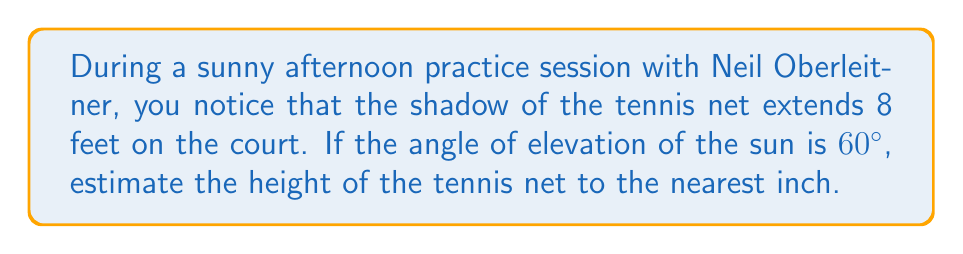Solve this math problem. To solve this problem, we'll use trigonometry, specifically the tangent function. Let's break it down step-by-step:

1) First, let's visualize the situation:

[asy]
import geometry;

size(200);
pair A = (0,0), B = (8,0), C = (0,4);
draw(A--B--C--A);
draw((-1,0)--(9,0), arrow=Arrow(TeXHead));
draw((0,-1)--(0,5), arrow=Arrow(TeXHead));
label("8 ft", (4,0), S);
label("h", (0,2), W);
label("60°", (0,0), NE);
label("x", (9,0), S);
label("y", (0,5), W);
[/asy]

2) In this right triangle, we know:
   - The adjacent side (shadow length) is 8 feet
   - The angle of elevation is 60°
   - We need to find the opposite side (net height)

3) The tangent of an angle in a right triangle is the ratio of the opposite side to the adjacent side:

   $$ \tan \theta = \frac{\text{opposite}}{\text{adjacent}} $$

4) We can write this as an equation:

   $$ \tan 60° = \frac{\text{net height}}{8} $$

5) We know that $\tan 60° = \sqrt{3}$, so we can substitute this:

   $$ \sqrt{3} = \frac{\text{net height}}{8} $$

6) To solve for the net height, multiply both sides by 8:

   $$ 8\sqrt{3} = \text{net height} $$

7) Calculate the result:
   $$ 8\sqrt{3} \approx 13.856 \text{ feet} $$

8) Convert to inches (1 foot = 12 inches):
   $$ 13.856 \text{ feet} \times 12 \text{ inches/foot} \approx 166.27 \text{ inches} $$

9) Rounding to the nearest inch:
   $$ 166.27 \text{ inches} \approx 166 \text{ inches} $$
Answer: The estimated height of the tennis net is 166 inches. 